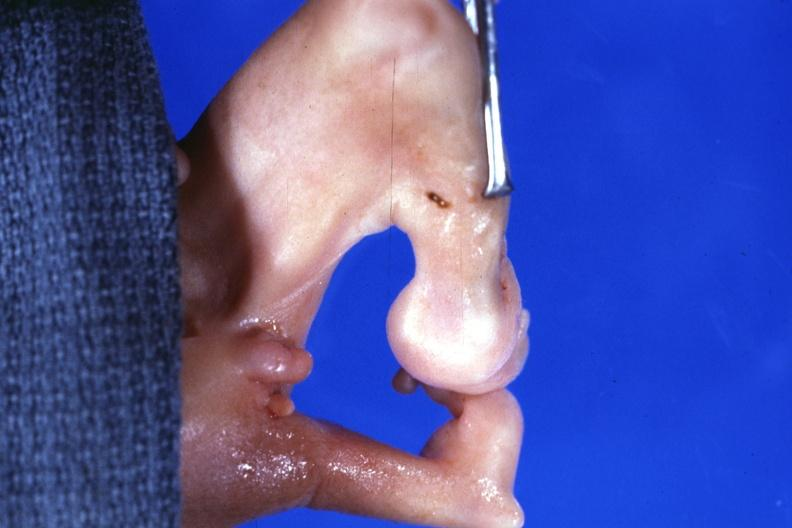re view looking down on heads present?
Answer the question using a single word or phrase. No 